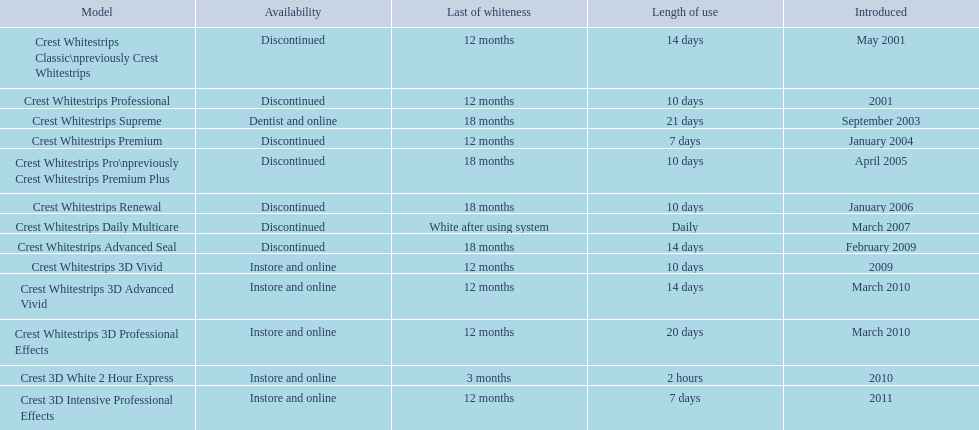Which models are still available? Crest Whitestrips Supreme, Crest Whitestrips 3D Vivid, Crest Whitestrips 3D Advanced Vivid, Crest Whitestrips 3D Professional Effects, Crest 3D White 2 Hour Express, Crest 3D Intensive Professional Effects. Of those, which were introduced prior to 2011? Crest Whitestrips Supreme, Crest Whitestrips 3D Vivid, Crest Whitestrips 3D Advanced Vivid, Crest Whitestrips 3D Professional Effects, Crest 3D White 2 Hour Express. Among those models, which ones had to be used at least 14 days? Crest Whitestrips Supreme, Crest Whitestrips 3D Advanced Vivid, Crest Whitestrips 3D Professional Effects. Which of those lasted longer than 12 months? Crest Whitestrips Supreme. 